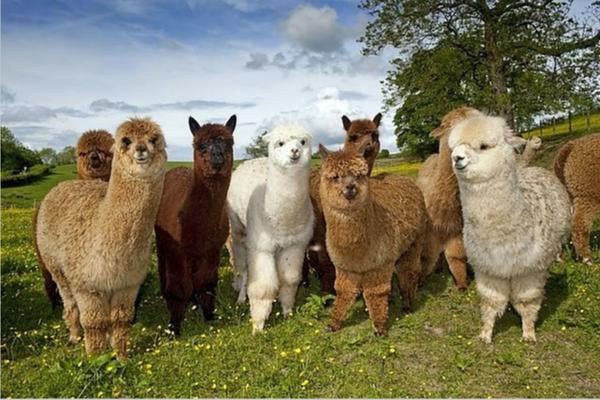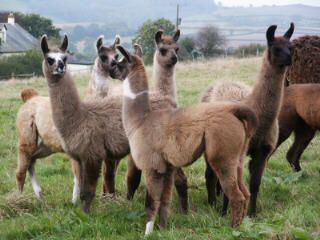The first image is the image on the left, the second image is the image on the right. For the images displayed, is the sentence "IN at least one image there are six llamas standing on grass." factually correct? Answer yes or no. Yes. The first image is the image on the left, the second image is the image on the right. Assess this claim about the two images: "One image shows a group of at least five llamas with rounded heads and fur in various solid colors standing and facing forward.". Correct or not? Answer yes or no. Yes. 